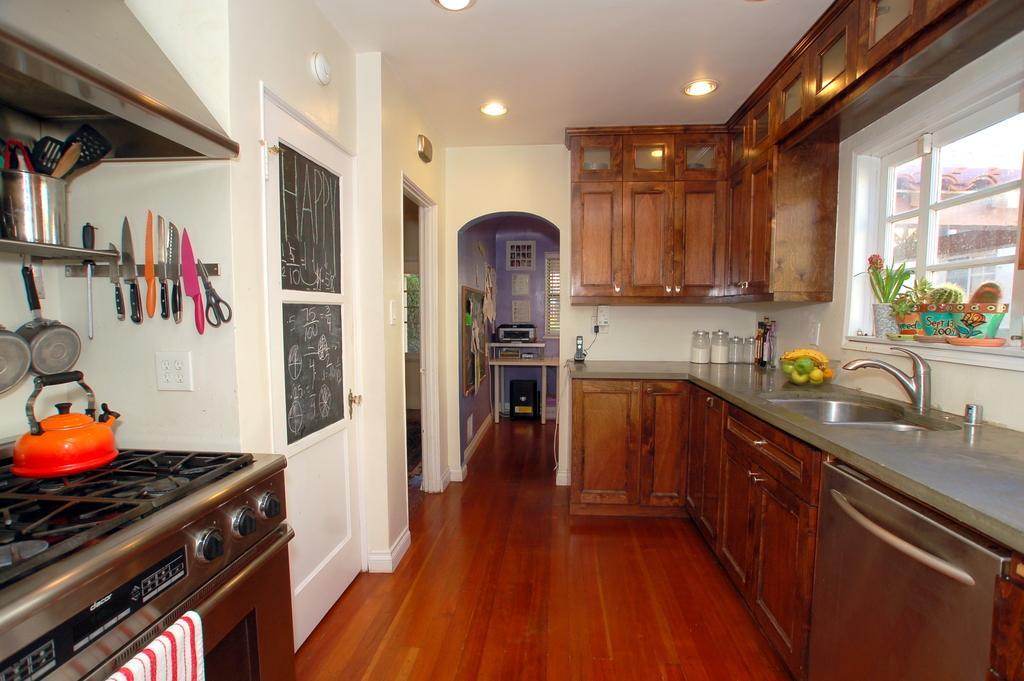Can you describe this image briefly? In this image we can see inside view of a house, there are knives, scissor on the wall, there are bowls on the racks, there is a stove, towel, there are jars on the kitchen slab, also we can see house plants, windows, door, there is are some objects on the table, we can see the ceiling, and there are some lights. 